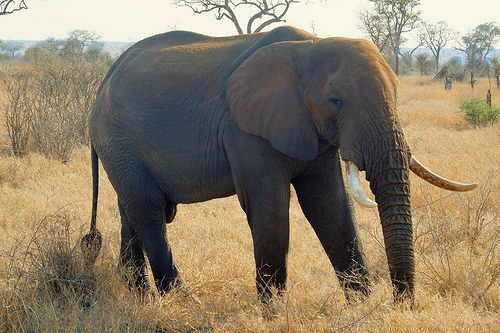<image>
Is the trunk under the head? Yes. The trunk is positioned underneath the head, with the head above it in the vertical space. 